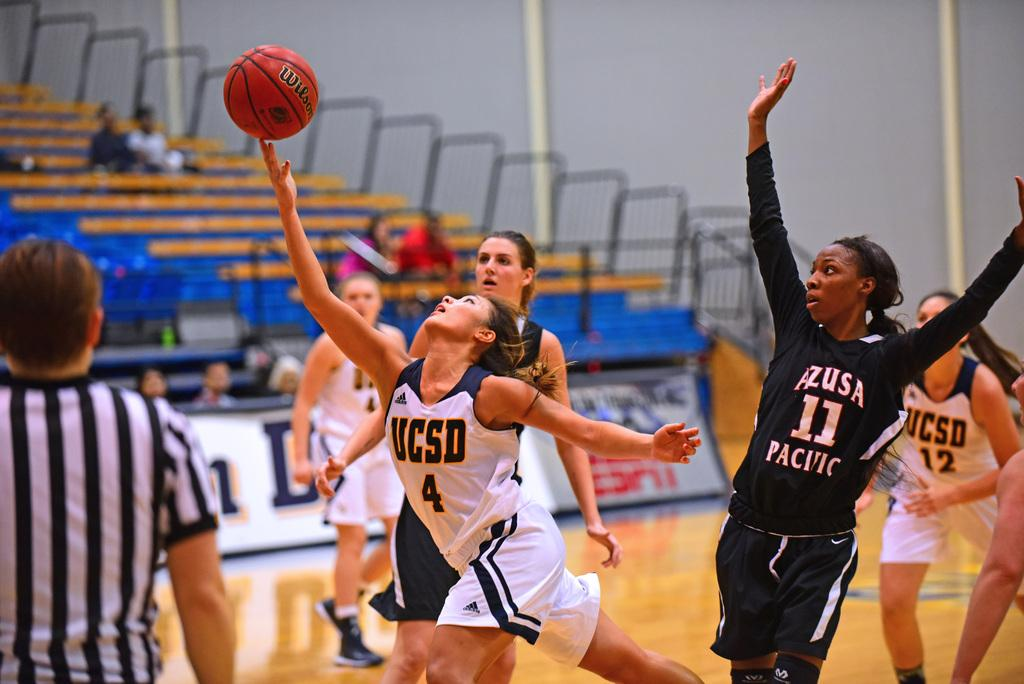<image>
Summarize the visual content of the image. The basket ball was made by the wilson company. 